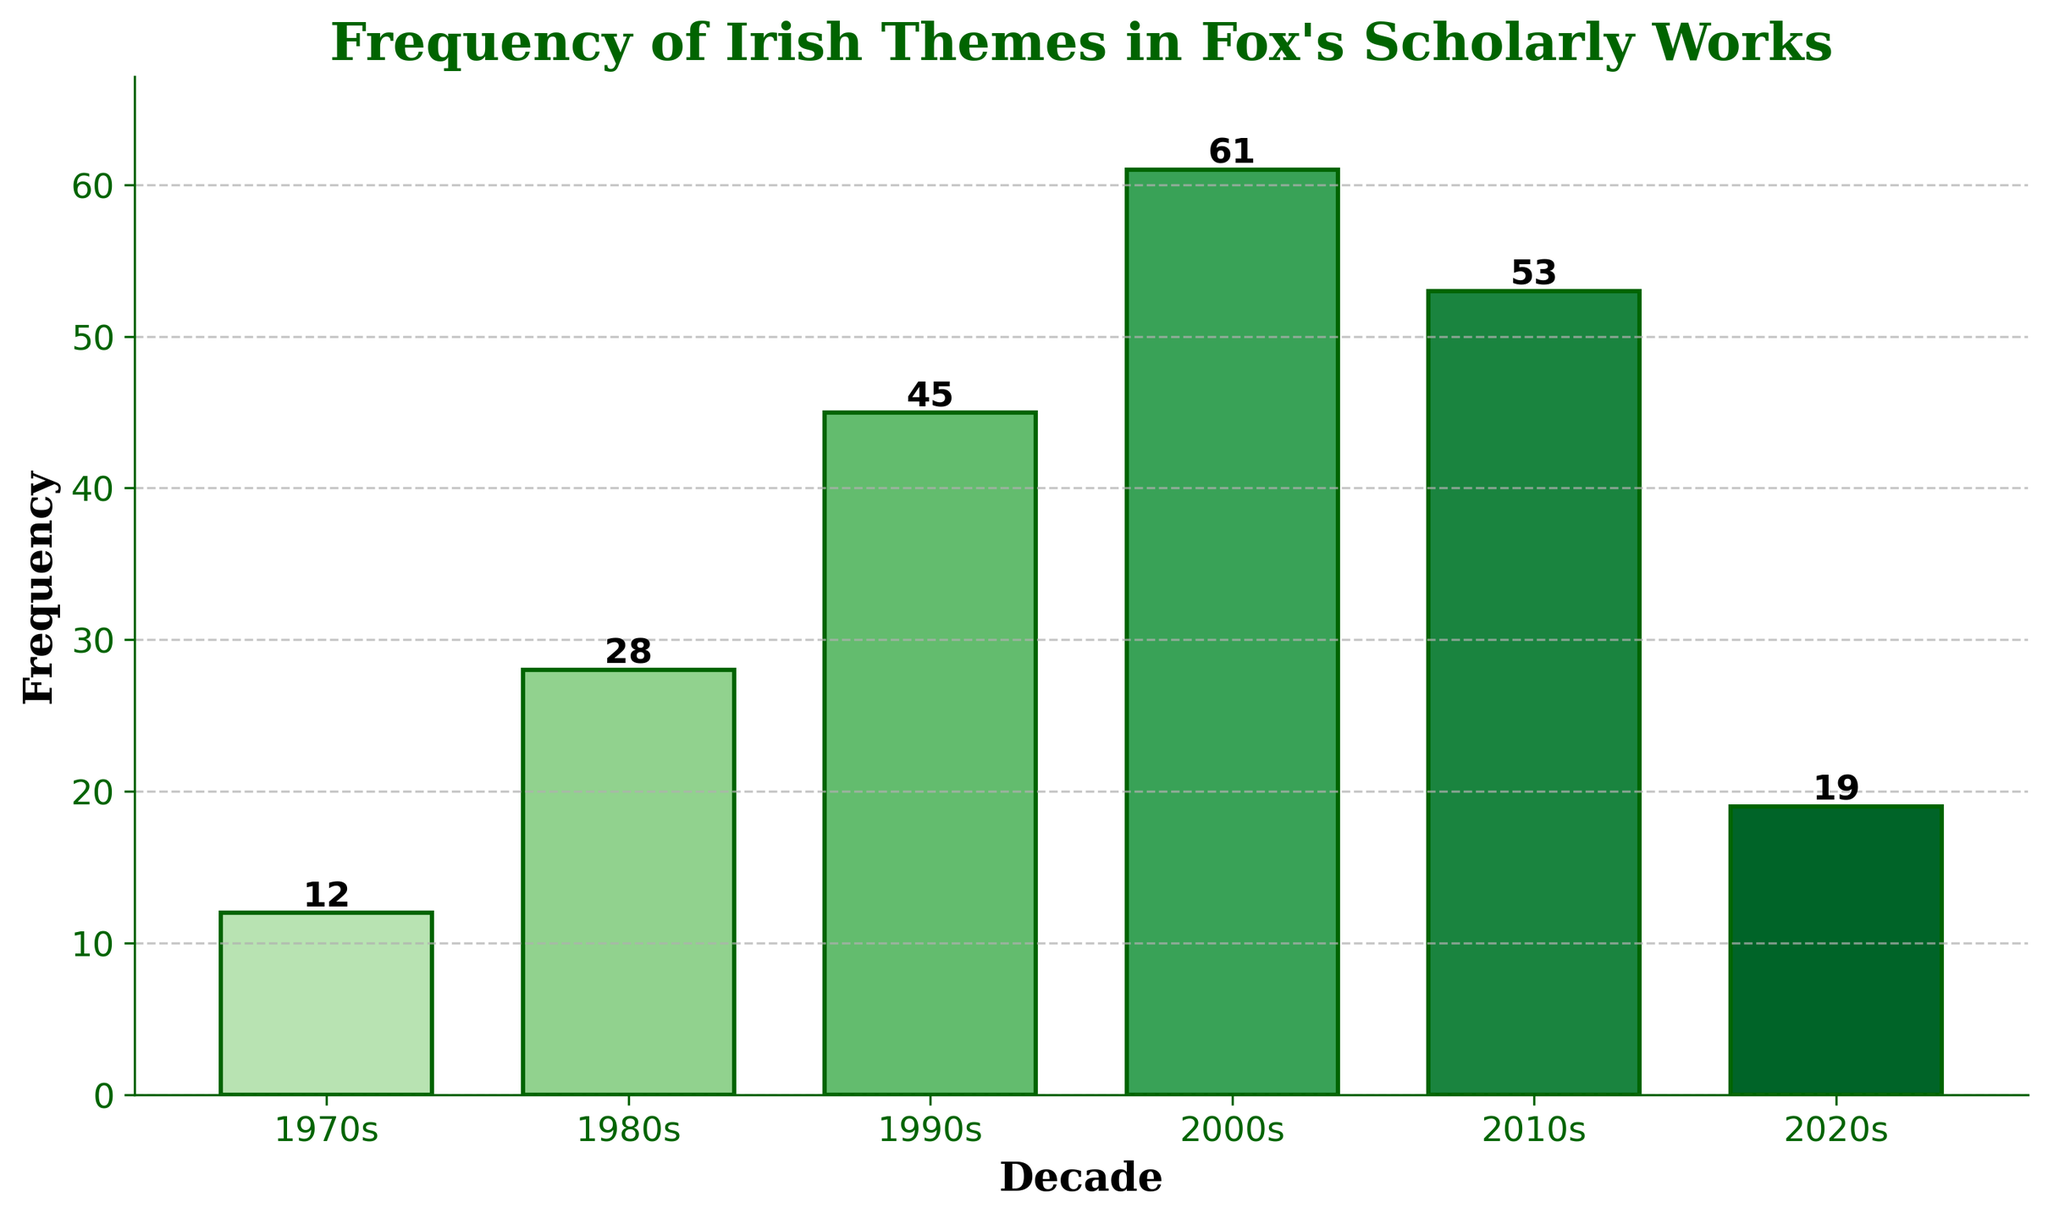What is the decade with the highest frequency of Irish themes in Fox's scholarly works? By examining the bars in the chart, the tallest bar represents the 2000s, indicating it has the highest frequency of Irish themes.
Answer: 2000s How much did the frequency increase from the 1970s to the 2000s? In the 1970s, the frequency was 12; in the 2000s, it was 61. The difference can be calculated by subtracting the frequency in the 1970s from the frequency in the 2000s: 61 - 12 = 49.
Answer: 49 Which decade has a lower frequency, the 1980s or the 2020s? By comparing the bars for both decades, the 2020s have a frequency of 19, while the 1980s have a higher frequency of 28.
Answer: 2020s What is the average frequency of Irish themes from the 1970s to the 2020s? Sum the frequencies from each decade (12 + 28 + 45 + 61 + 53 + 19 = 218), then divide by the number of decades (6). 218 / 6 = 36.33.
Answer: 36.33 How many times more frequent are Irish themes in the 2000s compared to the 1970s? The frequency in the 2000s is 61 and in the 1970s is 12. We calculate the ratio by dividing the frequency in the 2000s by the frequency in the 1970s: 61 / 12 ≈ 5.08.
Answer: 5.08 Which two consecutive decades show the largest increase in frequency of Irish themes? We calculate the difference between consecutive decades: 
1980s - 1970s = 28 - 12 = 16
1990s - 1980s = 45 - 28 = 17
2000s - 1990s = 61 - 45 = 16
2010s - 2000s = 53 - 61 = -8 (decrease)
2020s - 2010s = 19 - 53 = -34 (decrease)
The largest increase is between the 1980s and 1990s, with a difference of 17.
Answer: 1980s to 1990s What is the total frequency of Irish themes in Fox's works from the 1990s to the 2010s combined? Add the frequencies of the 1990s, 2000s, and 2010s: 45 + 61 + 53 = 159.
Answer: 159 What do the colors of the bars represent? The bars are shaded in varying intensities of green, which is a visual aid to differentiate the decades.
Answer: Different decades 